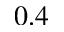<formula> <loc_0><loc_0><loc_500><loc_500>0 . 4</formula> 